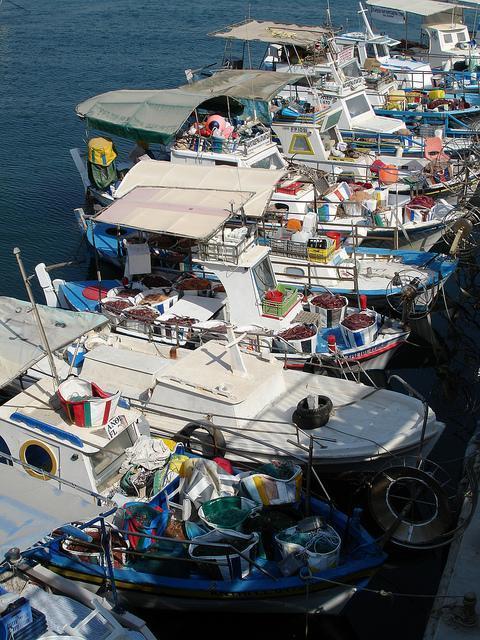How many boats can be seen?
Give a very brief answer. 10. How many boats are there?
Give a very brief answer. 11. How many giraffes are drinking?
Give a very brief answer. 0. 